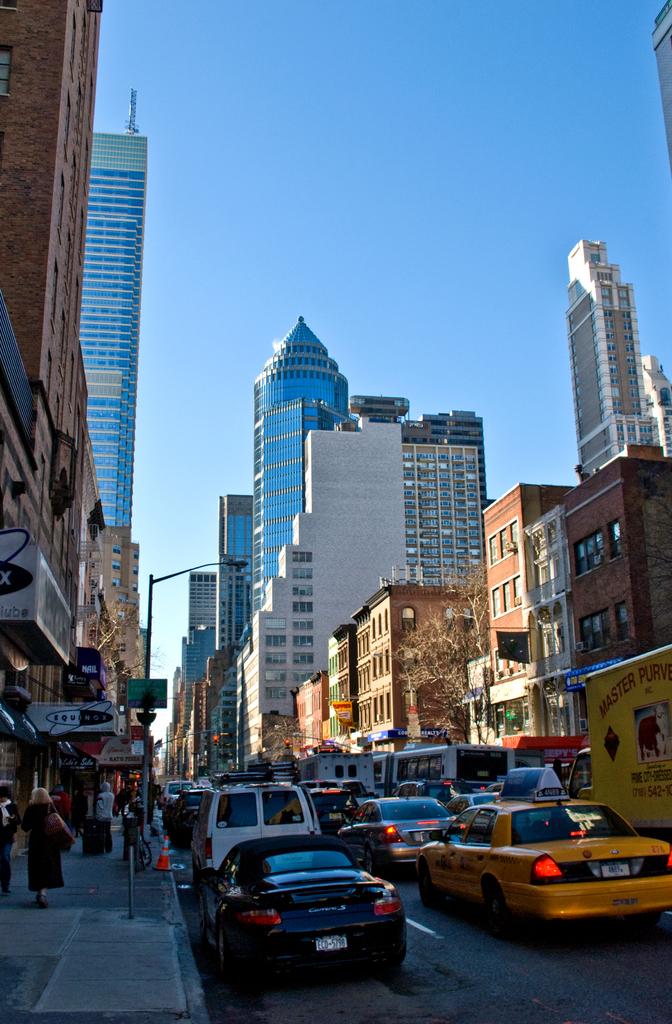What is the first word written on the right yellow truck?
Make the answer very short. Master. 